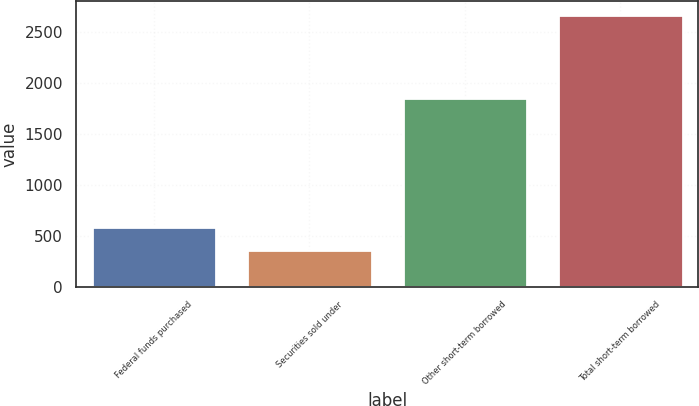<chart> <loc_0><loc_0><loc_500><loc_500><bar_chart><fcel>Federal funds purchased<fcel>Securities sold under<fcel>Other short-term borrowed<fcel>Total short-term borrowed<nl><fcel>586.6<fcel>355<fcel>1856<fcel>2671<nl></chart> 